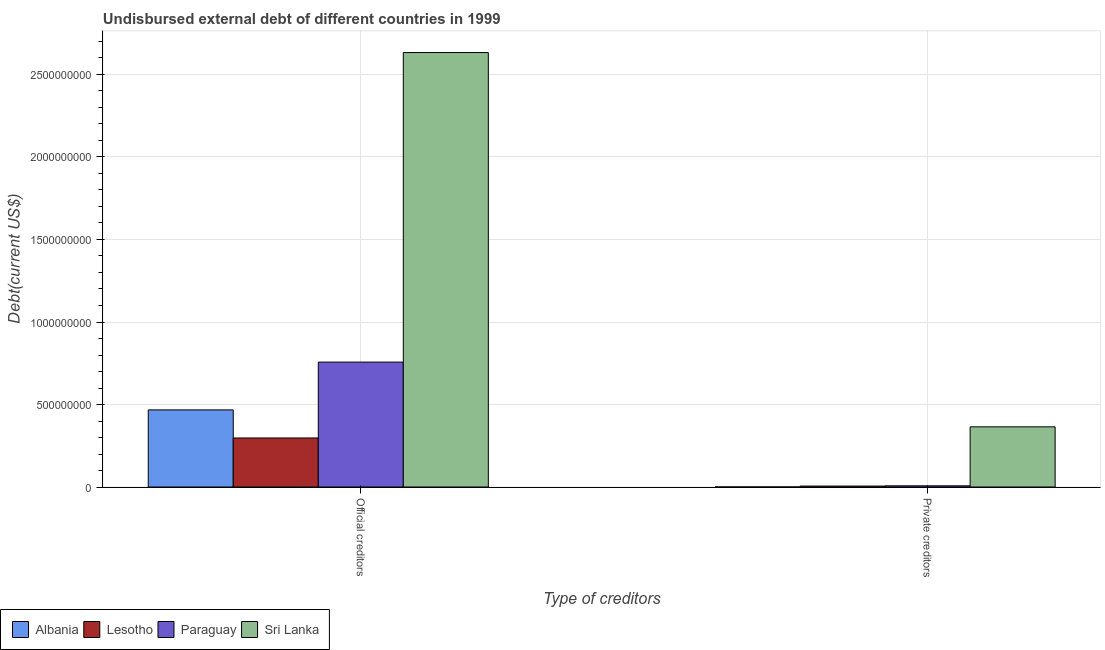How many groups of bars are there?
Your response must be concise. 2. How many bars are there on the 2nd tick from the left?
Offer a very short reply. 4. How many bars are there on the 1st tick from the right?
Your answer should be very brief. 4. What is the label of the 1st group of bars from the left?
Provide a short and direct response. Official creditors. What is the undisbursed external debt of official creditors in Albania?
Give a very brief answer. 4.67e+08. Across all countries, what is the maximum undisbursed external debt of private creditors?
Offer a very short reply. 3.65e+08. Across all countries, what is the minimum undisbursed external debt of private creditors?
Ensure brevity in your answer.  3.67e+05. In which country was the undisbursed external debt of private creditors maximum?
Make the answer very short. Sri Lanka. In which country was the undisbursed external debt of official creditors minimum?
Your answer should be compact. Lesotho. What is the total undisbursed external debt of private creditors in the graph?
Offer a very short reply. 3.78e+08. What is the difference between the undisbursed external debt of private creditors in Paraguay and that in Lesotho?
Ensure brevity in your answer.  1.47e+06. What is the difference between the undisbursed external debt of private creditors in Lesotho and the undisbursed external debt of official creditors in Albania?
Provide a short and direct response. -4.62e+08. What is the average undisbursed external debt of private creditors per country?
Your answer should be compact. 9.45e+07. What is the difference between the undisbursed external debt of private creditors and undisbursed external debt of official creditors in Paraguay?
Offer a very short reply. -7.50e+08. In how many countries, is the undisbursed external debt of official creditors greater than 800000000 US$?
Make the answer very short. 1. What is the ratio of the undisbursed external debt of private creditors in Sri Lanka to that in Paraguay?
Give a very brief answer. 50.51. What does the 4th bar from the left in Private creditors represents?
Make the answer very short. Sri Lanka. What does the 1st bar from the right in Private creditors represents?
Your answer should be compact. Sri Lanka. How many countries are there in the graph?
Make the answer very short. 4. Does the graph contain any zero values?
Keep it short and to the point. No. How many legend labels are there?
Keep it short and to the point. 4. What is the title of the graph?
Make the answer very short. Undisbursed external debt of different countries in 1999. Does "Indonesia" appear as one of the legend labels in the graph?
Your response must be concise. No. What is the label or title of the X-axis?
Offer a terse response. Type of creditors. What is the label or title of the Y-axis?
Ensure brevity in your answer.  Debt(current US$). What is the Debt(current US$) of Albania in Official creditors?
Keep it short and to the point. 4.67e+08. What is the Debt(current US$) of Lesotho in Official creditors?
Keep it short and to the point. 2.97e+08. What is the Debt(current US$) in Paraguay in Official creditors?
Your answer should be very brief. 7.57e+08. What is the Debt(current US$) of Sri Lanka in Official creditors?
Keep it short and to the point. 2.63e+09. What is the Debt(current US$) in Albania in Private creditors?
Give a very brief answer. 3.67e+05. What is the Debt(current US$) of Lesotho in Private creditors?
Your answer should be very brief. 5.75e+06. What is the Debt(current US$) of Paraguay in Private creditors?
Provide a succinct answer. 7.22e+06. What is the Debt(current US$) in Sri Lanka in Private creditors?
Offer a very short reply. 3.65e+08. Across all Type of creditors, what is the maximum Debt(current US$) of Albania?
Provide a succinct answer. 4.67e+08. Across all Type of creditors, what is the maximum Debt(current US$) of Lesotho?
Offer a very short reply. 2.97e+08. Across all Type of creditors, what is the maximum Debt(current US$) in Paraguay?
Your answer should be very brief. 7.57e+08. Across all Type of creditors, what is the maximum Debt(current US$) of Sri Lanka?
Provide a short and direct response. 2.63e+09. Across all Type of creditors, what is the minimum Debt(current US$) in Albania?
Your answer should be compact. 3.67e+05. Across all Type of creditors, what is the minimum Debt(current US$) of Lesotho?
Ensure brevity in your answer.  5.75e+06. Across all Type of creditors, what is the minimum Debt(current US$) of Paraguay?
Provide a short and direct response. 7.22e+06. Across all Type of creditors, what is the minimum Debt(current US$) of Sri Lanka?
Ensure brevity in your answer.  3.65e+08. What is the total Debt(current US$) of Albania in the graph?
Offer a terse response. 4.68e+08. What is the total Debt(current US$) of Lesotho in the graph?
Offer a very short reply. 3.03e+08. What is the total Debt(current US$) in Paraguay in the graph?
Provide a short and direct response. 7.64e+08. What is the total Debt(current US$) of Sri Lanka in the graph?
Give a very brief answer. 3.00e+09. What is the difference between the Debt(current US$) of Albania in Official creditors and that in Private creditors?
Ensure brevity in your answer.  4.67e+08. What is the difference between the Debt(current US$) in Lesotho in Official creditors and that in Private creditors?
Offer a very short reply. 2.91e+08. What is the difference between the Debt(current US$) in Paraguay in Official creditors and that in Private creditors?
Your answer should be very brief. 7.50e+08. What is the difference between the Debt(current US$) of Sri Lanka in Official creditors and that in Private creditors?
Provide a succinct answer. 2.27e+09. What is the difference between the Debt(current US$) in Albania in Official creditors and the Debt(current US$) in Lesotho in Private creditors?
Offer a very short reply. 4.62e+08. What is the difference between the Debt(current US$) of Albania in Official creditors and the Debt(current US$) of Paraguay in Private creditors?
Keep it short and to the point. 4.60e+08. What is the difference between the Debt(current US$) in Albania in Official creditors and the Debt(current US$) in Sri Lanka in Private creditors?
Your answer should be compact. 1.03e+08. What is the difference between the Debt(current US$) in Lesotho in Official creditors and the Debt(current US$) in Paraguay in Private creditors?
Keep it short and to the point. 2.90e+08. What is the difference between the Debt(current US$) of Lesotho in Official creditors and the Debt(current US$) of Sri Lanka in Private creditors?
Keep it short and to the point. -6.75e+07. What is the difference between the Debt(current US$) of Paraguay in Official creditors and the Debt(current US$) of Sri Lanka in Private creditors?
Your response must be concise. 3.92e+08. What is the average Debt(current US$) of Albania per Type of creditors?
Make the answer very short. 2.34e+08. What is the average Debt(current US$) of Lesotho per Type of creditors?
Keep it short and to the point. 1.51e+08. What is the average Debt(current US$) in Paraguay per Type of creditors?
Ensure brevity in your answer.  3.82e+08. What is the average Debt(current US$) in Sri Lanka per Type of creditors?
Keep it short and to the point. 1.50e+09. What is the difference between the Debt(current US$) of Albania and Debt(current US$) of Lesotho in Official creditors?
Provide a short and direct response. 1.70e+08. What is the difference between the Debt(current US$) of Albania and Debt(current US$) of Paraguay in Official creditors?
Provide a succinct answer. -2.90e+08. What is the difference between the Debt(current US$) in Albania and Debt(current US$) in Sri Lanka in Official creditors?
Make the answer very short. -2.17e+09. What is the difference between the Debt(current US$) in Lesotho and Debt(current US$) in Paraguay in Official creditors?
Your answer should be very brief. -4.60e+08. What is the difference between the Debt(current US$) in Lesotho and Debt(current US$) in Sri Lanka in Official creditors?
Ensure brevity in your answer.  -2.34e+09. What is the difference between the Debt(current US$) in Paraguay and Debt(current US$) in Sri Lanka in Official creditors?
Your response must be concise. -1.88e+09. What is the difference between the Debt(current US$) of Albania and Debt(current US$) of Lesotho in Private creditors?
Offer a very short reply. -5.38e+06. What is the difference between the Debt(current US$) of Albania and Debt(current US$) of Paraguay in Private creditors?
Keep it short and to the point. -6.85e+06. What is the difference between the Debt(current US$) in Albania and Debt(current US$) in Sri Lanka in Private creditors?
Your answer should be compact. -3.64e+08. What is the difference between the Debt(current US$) in Lesotho and Debt(current US$) in Paraguay in Private creditors?
Your response must be concise. -1.47e+06. What is the difference between the Debt(current US$) in Lesotho and Debt(current US$) in Sri Lanka in Private creditors?
Your response must be concise. -3.59e+08. What is the difference between the Debt(current US$) of Paraguay and Debt(current US$) of Sri Lanka in Private creditors?
Ensure brevity in your answer.  -3.57e+08. What is the ratio of the Debt(current US$) of Albania in Official creditors to that in Private creditors?
Your answer should be compact. 1273.33. What is the ratio of the Debt(current US$) of Lesotho in Official creditors to that in Private creditors?
Provide a short and direct response. 51.66. What is the ratio of the Debt(current US$) in Paraguay in Official creditors to that in Private creditors?
Your answer should be compact. 104.86. What is the ratio of the Debt(current US$) in Sri Lanka in Official creditors to that in Private creditors?
Provide a short and direct response. 7.22. What is the difference between the highest and the second highest Debt(current US$) in Albania?
Provide a succinct answer. 4.67e+08. What is the difference between the highest and the second highest Debt(current US$) in Lesotho?
Offer a terse response. 2.91e+08. What is the difference between the highest and the second highest Debt(current US$) in Paraguay?
Make the answer very short. 7.50e+08. What is the difference between the highest and the second highest Debt(current US$) of Sri Lanka?
Give a very brief answer. 2.27e+09. What is the difference between the highest and the lowest Debt(current US$) of Albania?
Offer a terse response. 4.67e+08. What is the difference between the highest and the lowest Debt(current US$) in Lesotho?
Make the answer very short. 2.91e+08. What is the difference between the highest and the lowest Debt(current US$) in Paraguay?
Your answer should be compact. 7.50e+08. What is the difference between the highest and the lowest Debt(current US$) in Sri Lanka?
Keep it short and to the point. 2.27e+09. 